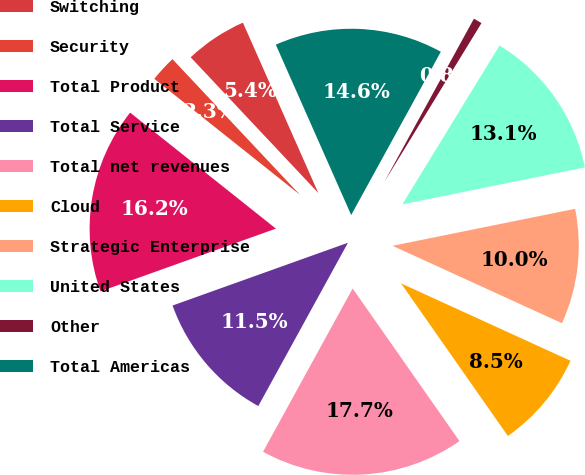Convert chart. <chart><loc_0><loc_0><loc_500><loc_500><pie_chart><fcel>Switching<fcel>Security<fcel>Total Product<fcel>Total Service<fcel>Total net revenues<fcel>Cloud<fcel>Strategic Enterprise<fcel>United States<fcel>Other<fcel>Total Americas<nl><fcel>5.38%<fcel>2.29%<fcel>16.17%<fcel>11.54%<fcel>17.71%<fcel>8.46%<fcel>10.0%<fcel>13.08%<fcel>0.75%<fcel>14.62%<nl></chart> 